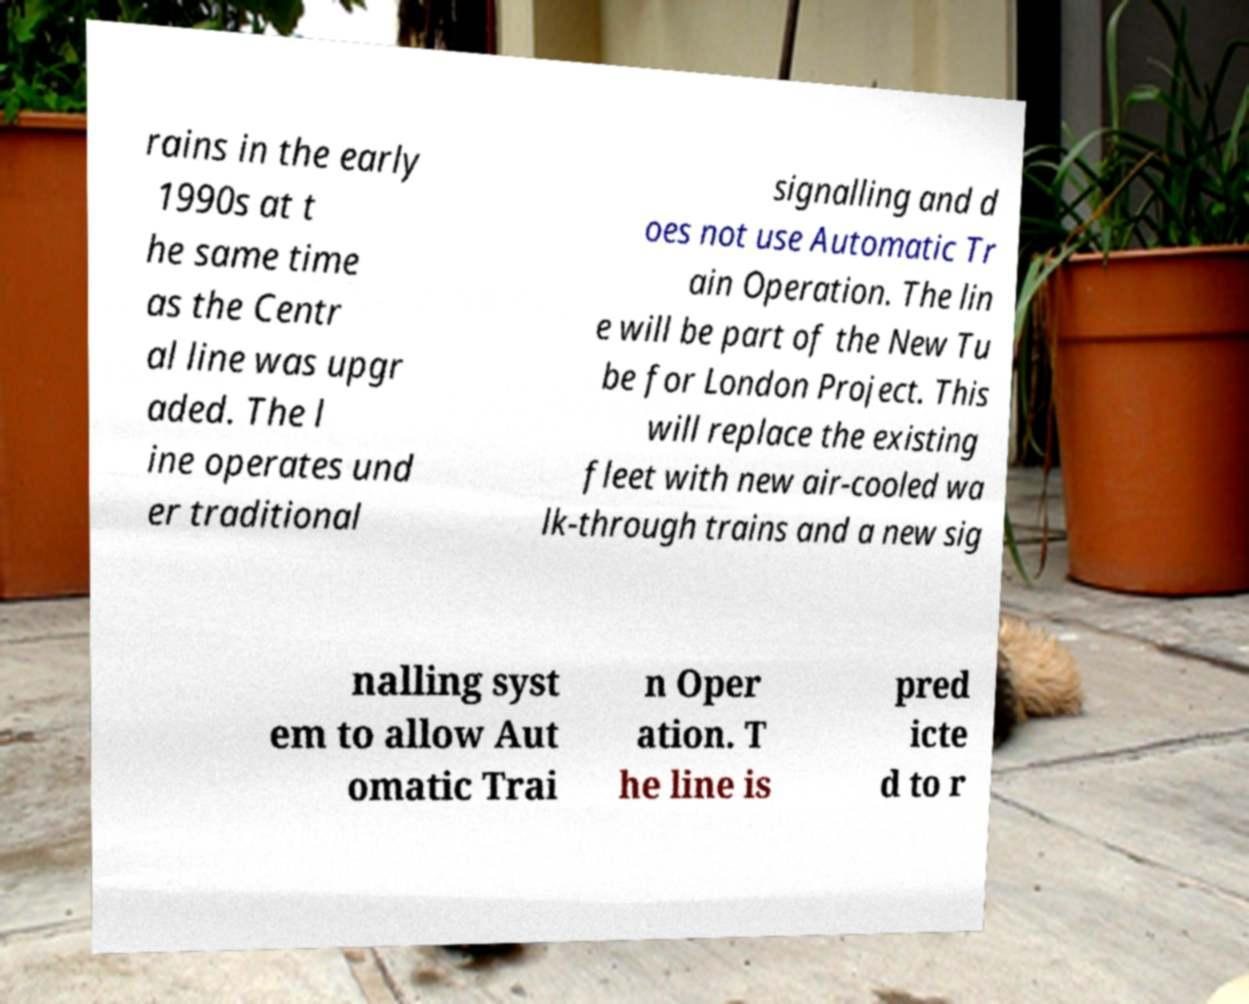Please identify and transcribe the text found in this image. rains in the early 1990s at t he same time as the Centr al line was upgr aded. The l ine operates und er traditional signalling and d oes not use Automatic Tr ain Operation. The lin e will be part of the New Tu be for London Project. This will replace the existing fleet with new air-cooled wa lk-through trains and a new sig nalling syst em to allow Aut omatic Trai n Oper ation. T he line is pred icte d to r 